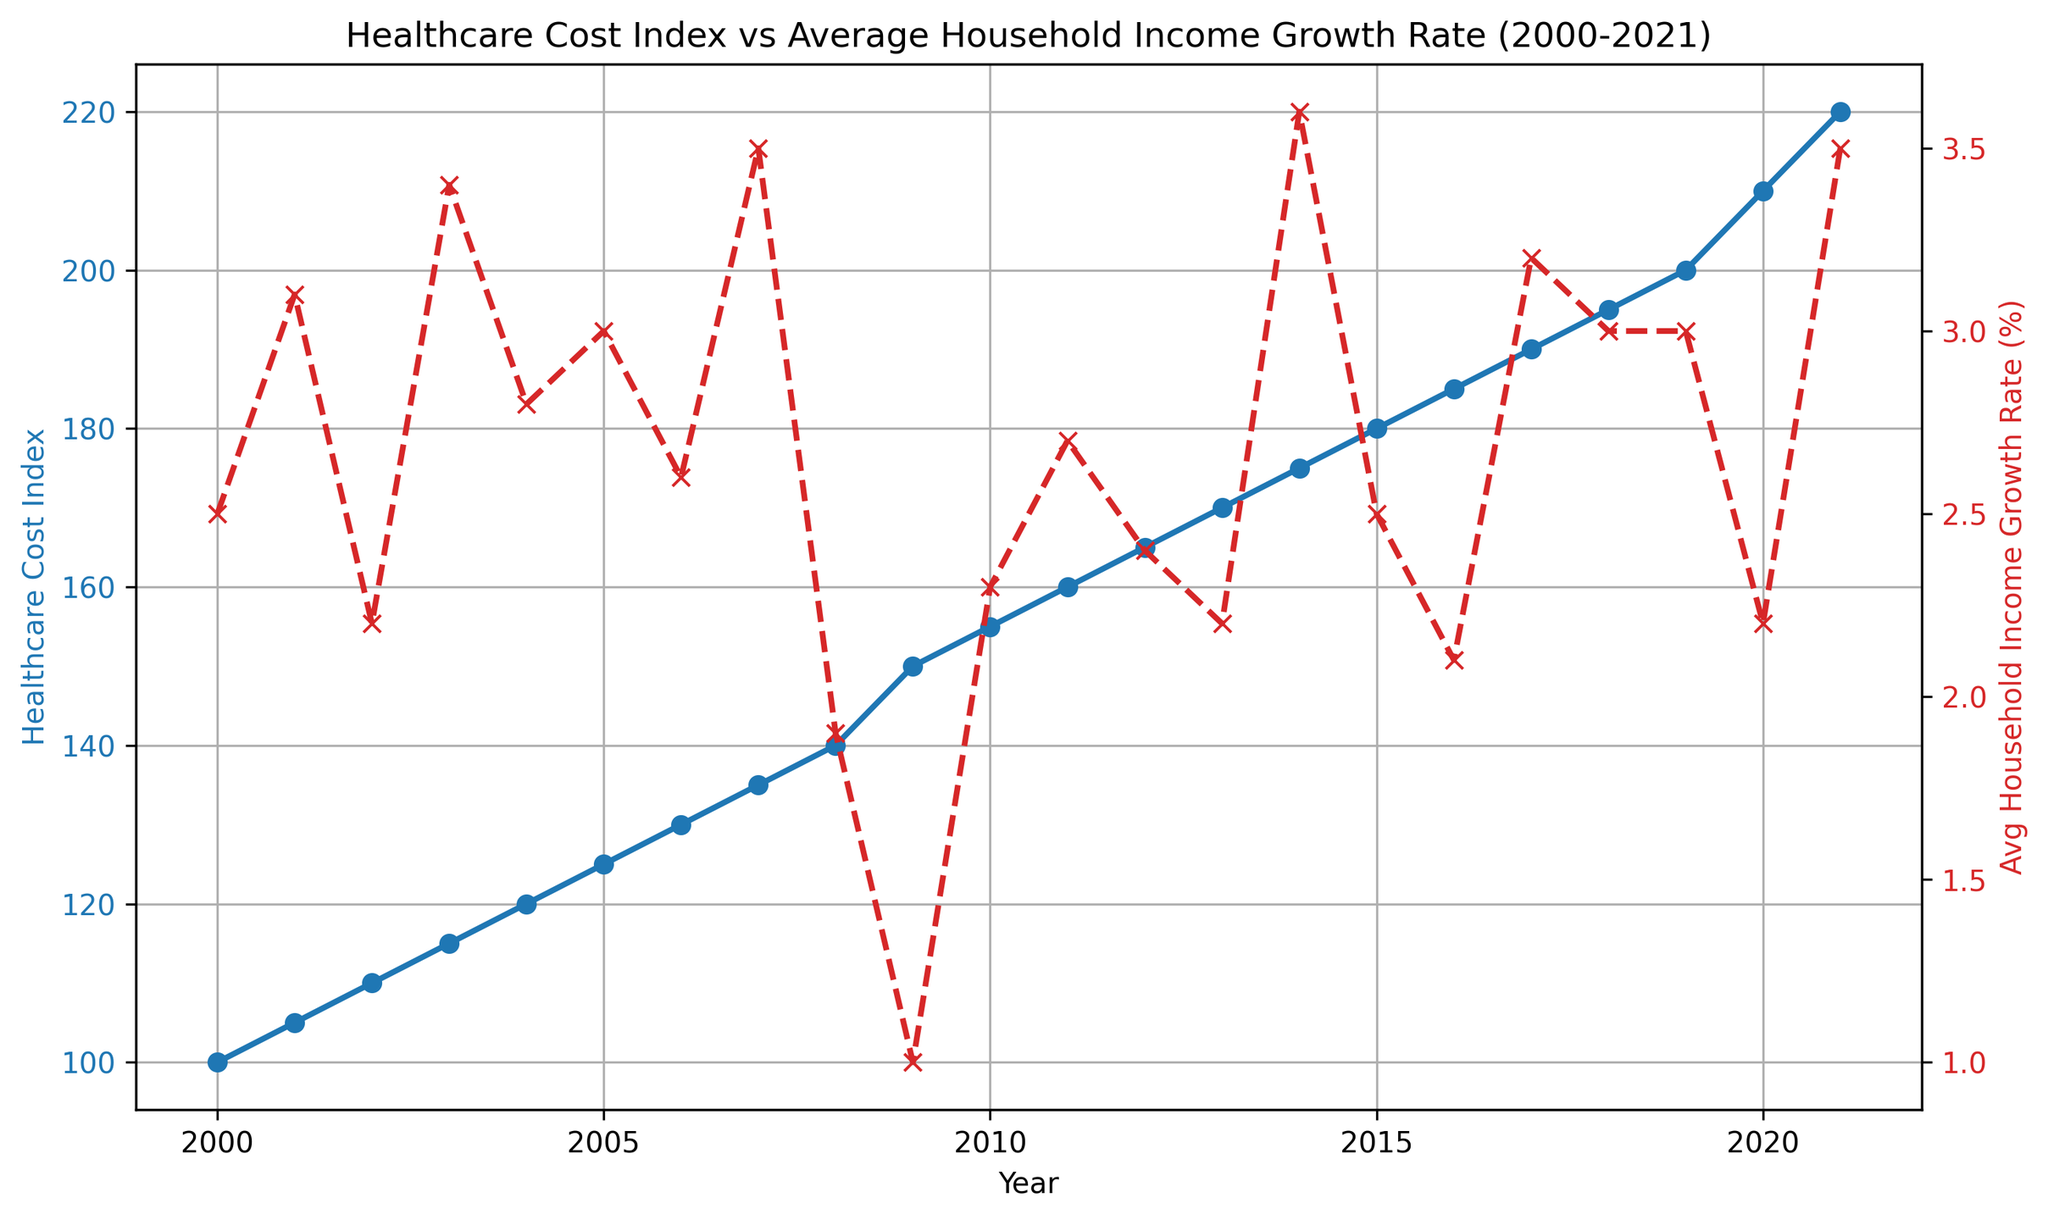What is the trend of the Healthcare Cost Index over the years from 2000 to 2021? The Healthcare Cost Index increases consistently over the years. Starting from 100 in 2000, it gradually rises to 220 by 2021.
Answer: Increasing Which year shows the highest Average Household Income Growth Rate? The highest Average Household Income Growth Rate is observed in 2021, with a growth rate of 3.5%.
Answer: 2021 How does the Average Household Income Growth Rate change in 2009 compared to 2008? In 2008, the growth rate is 1.9%. In 2009, it drops significantly to 1.0%. This is a decrease of 0.9%.
Answer: It decreases by 0.9% Compare the overall trend of the Healthcare Cost Index to the Average Household Income Growth Rate. Do they have similar trends? The Healthcare Cost Index increases steadily over time, whereas the Average Household Income Growth Rate fluctuates. For example, the growth rate drops from 3.5% in 2007 to 1.0% in 2009, indicating they do not share a consistent trend.
Answer: No, they do not have similar trends What can be said about the years when the Average Household Income Growth Rate is above 3%? The years with an Average Household Income Growth Rate above 3% are 2001, 2003, 2007, 2014, 2017, 2019, and 2021. In these years, the growth rate is relatively higher compared to other years.
Answer: These years have a higher growth rate What is the difference in the Healthcare Cost Index between the years 2010 and 2020? The Healthcare Cost Index in 2010 is 155, and in 2020 it is 210. The difference is 210 - 155 = 55.
Answer: 55 During which period is the Average Household Income Growth Rate the lowest? The Average Household Income Growth Rate is the lowest in 2009, at 1.0%.
Answer: 2009 If the trend of the Healthcare Cost Index continues, predict its value in 2022 considering the average increase per year. From 2000 to 2021, the Healthcare Cost Index increases from 100 to 220. This is an increase of 220 - 100 = 120 over 21 years, giving an average increase of 120/21 ≈ 5.71 per year. Therefore, the predicted value for 2022 would be approximately 220 + 5.71 = 225.71.
Answer: Approximately 225.71 Is there any year where both the Healthcare Cost Index and the Average Household Income Growth Rate increased compared to the previous year? Yes, for example, in 2021, both the Healthcare Cost Index (increased from 210 to 220) and the Average Household Income Growth Rate (increased from 2.2% to 3.5%) increased compared to 2020.
Answer: Yes, in 2021 Which year has the highest Healthcare Cost Index, and what is the corresponding Average Household Income Growth Rate for that year? The year with the highest Healthcare Cost Index is 2021, with an index of 220. The corresponding Average Household Income Growth Rate for 2021 is 3.5%.
Answer: 2021, 3.5% 